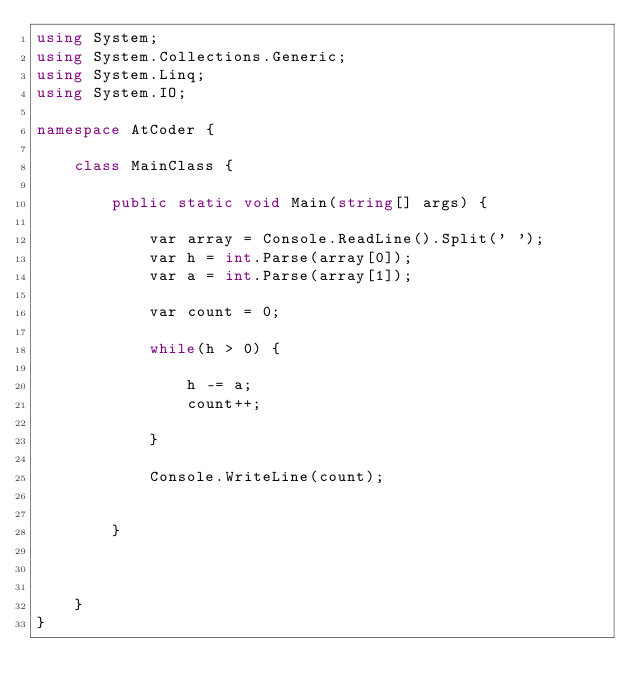Convert code to text. <code><loc_0><loc_0><loc_500><loc_500><_C#_>using System;
using System.Collections.Generic;
using System.Linq;
using System.IO;

namespace AtCoder {

    class MainClass {

        public static void Main(string[] args) {

            var array = Console.ReadLine().Split(' ');
            var h = int.Parse(array[0]);
            var a = int.Parse(array[1]);

            var count = 0;

            while(h > 0) {

                h -= a;
                count++;

            }

            Console.WriteLine(count);


        }

        

    }
}
</code> 